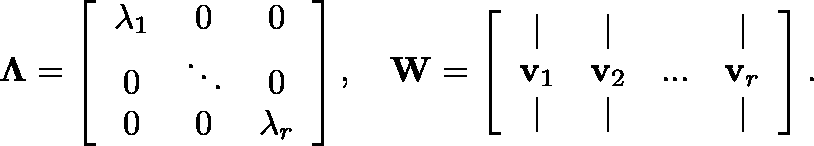<formula> <loc_0><loc_0><loc_500><loc_500>\Lambda = \left [ \begin{array} { c c c } { \lambda _ { 1 } } & { 0 } & { 0 } \\ { 0 } & { \ddots } & { 0 } \\ { 0 } & { 0 } & { \lambda _ { r } } \end{array} \right ] , \quad W = \left [ \begin{array} { c c c c } { | } & { | } & & { | } \\ { \mathbf v _ { 1 } } & { \mathbf v _ { 2 } } & { \dots } & { \mathbf v _ { r } } \\ { | } & { | } & & { | } \end{array} \right ] .</formula> 